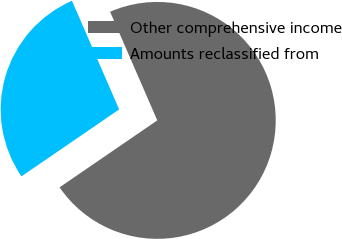<chart> <loc_0><loc_0><loc_500><loc_500><pie_chart><fcel>Other comprehensive income<fcel>Amounts reclassified from<nl><fcel>71.96%<fcel>28.04%<nl></chart> 